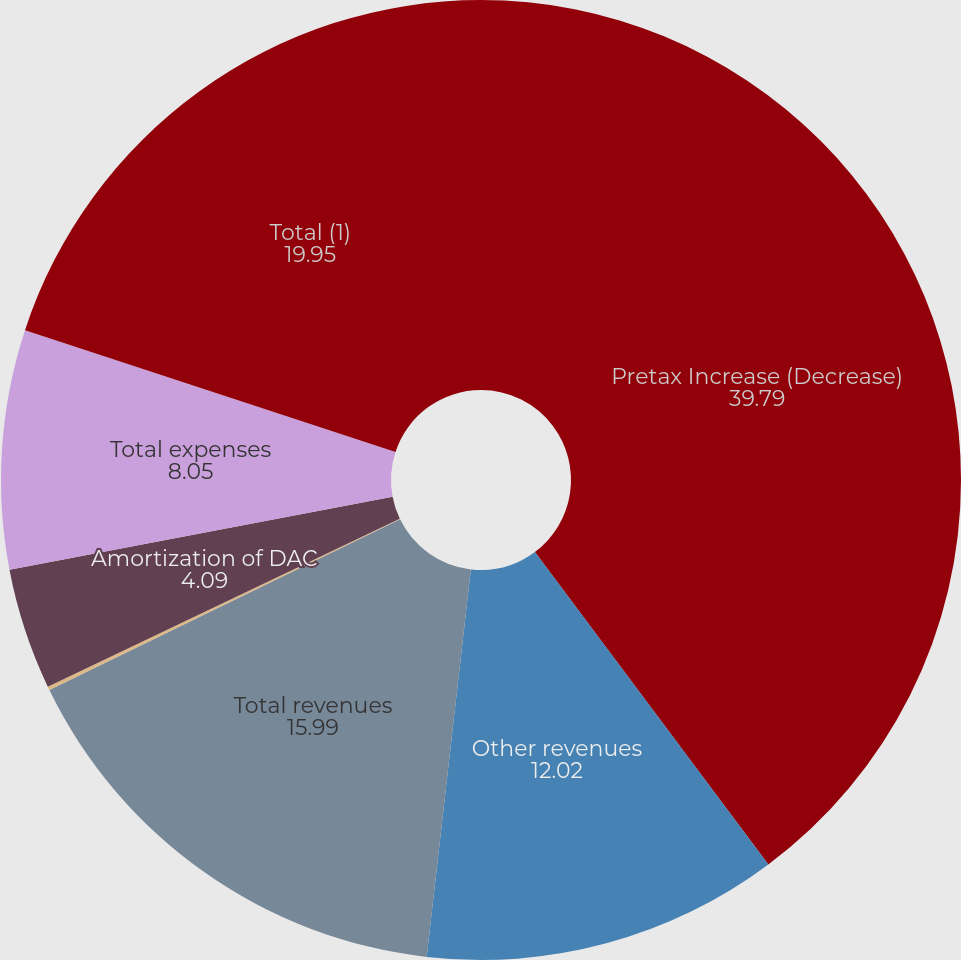<chart> <loc_0><loc_0><loc_500><loc_500><pie_chart><fcel>Pretax Increase (Decrease)<fcel>Other revenues<fcel>Total revenues<fcel>Benefits claims losses and<fcel>Amortization of DAC<fcel>Total expenses<fcel>Total (1)<nl><fcel>39.79%<fcel>12.02%<fcel>15.99%<fcel>0.12%<fcel>4.09%<fcel>8.05%<fcel>19.95%<nl></chart> 